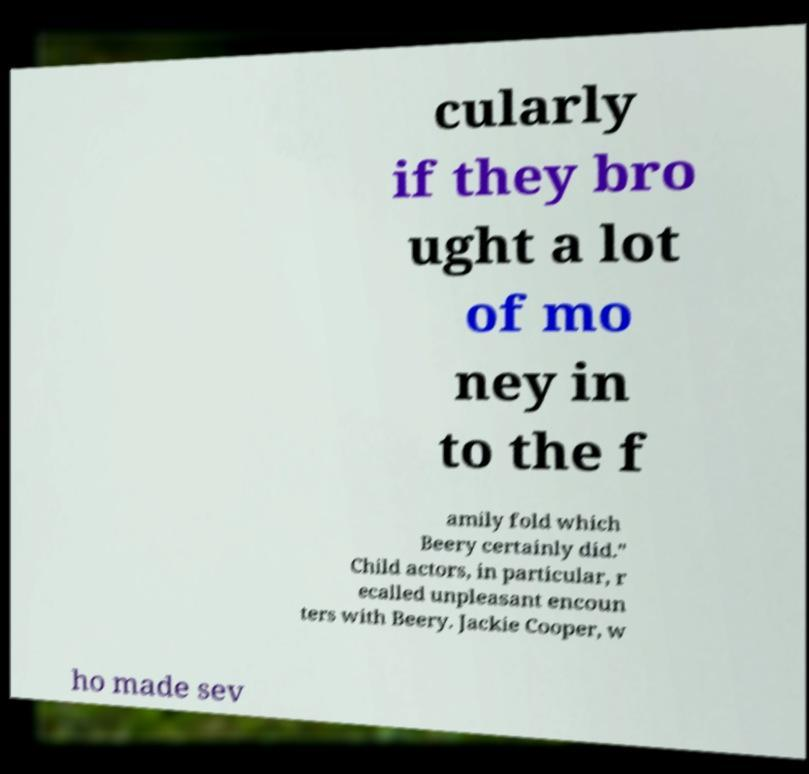Can you read and provide the text displayed in the image?This photo seems to have some interesting text. Can you extract and type it out for me? cularly if they bro ught a lot of mo ney in to the f amily fold which Beery certainly did." Child actors, in particular, r ecalled unpleasant encoun ters with Beery. Jackie Cooper, w ho made sev 